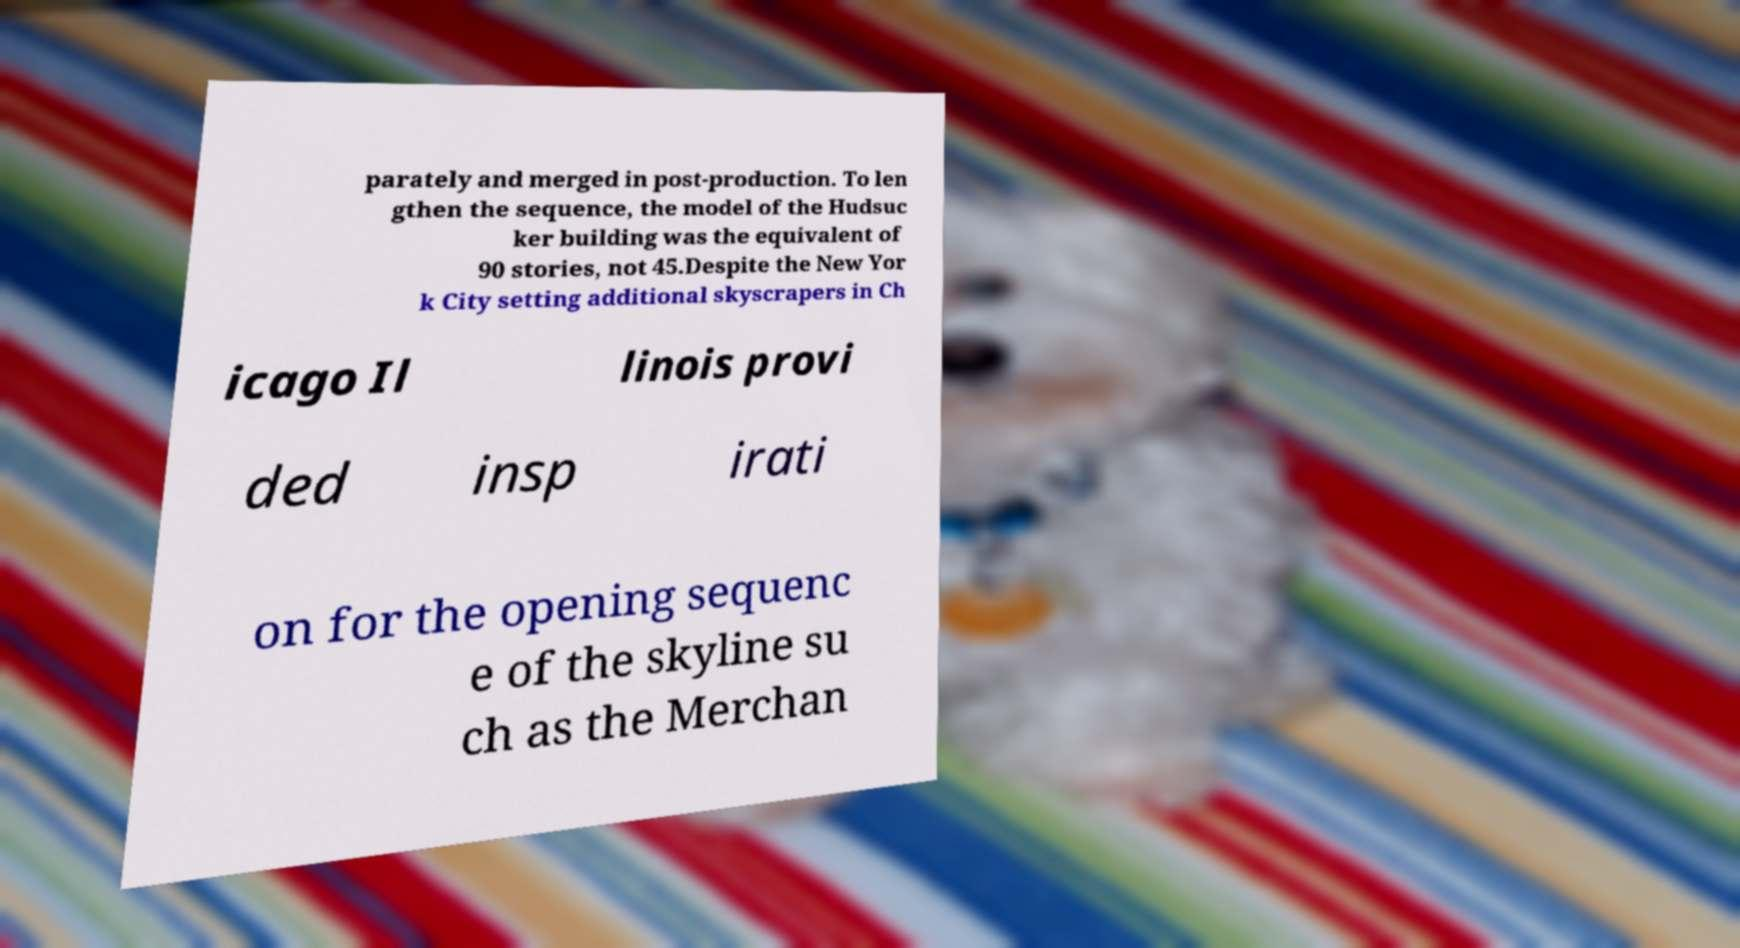For documentation purposes, I need the text within this image transcribed. Could you provide that? parately and merged in post-production. To len gthen the sequence, the model of the Hudsuc ker building was the equivalent of 90 stories, not 45.Despite the New Yor k City setting additional skyscrapers in Ch icago Il linois provi ded insp irati on for the opening sequenc e of the skyline su ch as the Merchan 